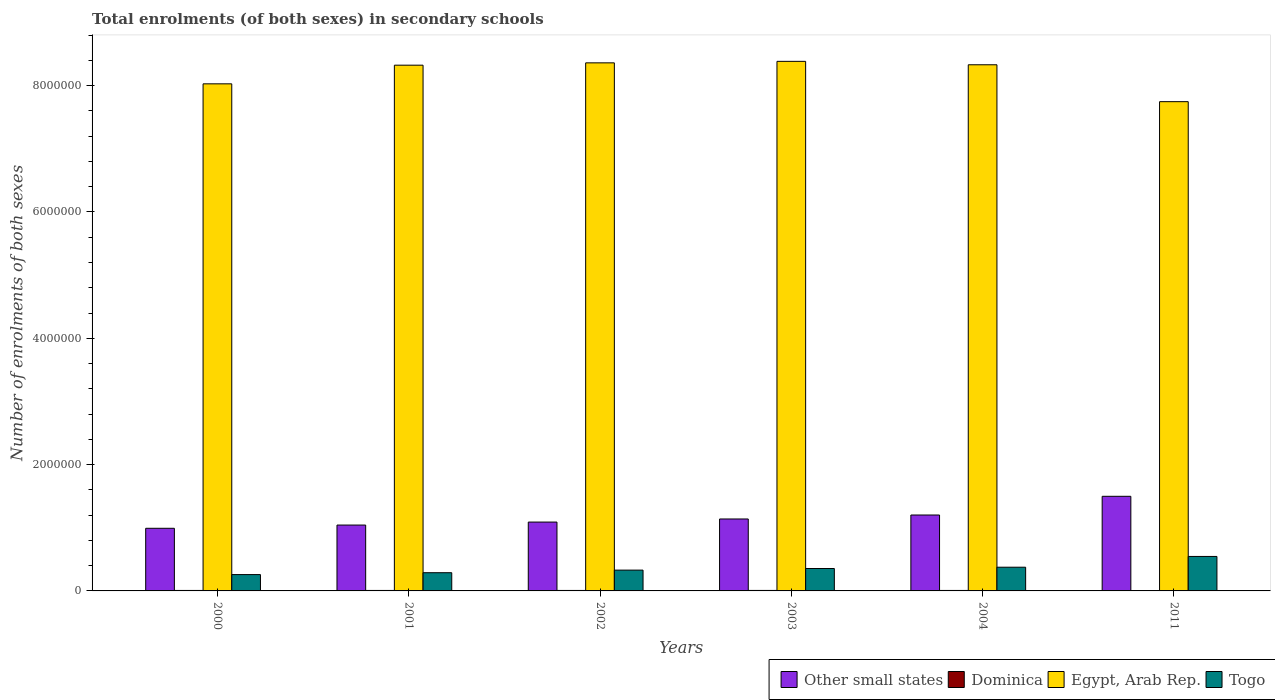How many groups of bars are there?
Provide a succinct answer. 6. Are the number of bars per tick equal to the number of legend labels?
Keep it short and to the point. Yes. How many bars are there on the 2nd tick from the left?
Make the answer very short. 4. In how many cases, is the number of bars for a given year not equal to the number of legend labels?
Provide a short and direct response. 0. What is the number of enrolments in secondary schools in Other small states in 2004?
Give a very brief answer. 1.20e+06. Across all years, what is the maximum number of enrolments in secondary schools in Dominica?
Provide a succinct answer. 7724. Across all years, what is the minimum number of enrolments in secondary schools in Dominica?
Offer a very short reply. 6507. What is the total number of enrolments in secondary schools in Dominica in the graph?
Your response must be concise. 4.41e+04. What is the difference between the number of enrolments in secondary schools in Togo in 2001 and that in 2003?
Keep it short and to the point. -6.66e+04. What is the difference between the number of enrolments in secondary schools in Other small states in 2011 and the number of enrolments in secondary schools in Egypt, Arab Rep. in 2002?
Provide a short and direct response. -6.86e+06. What is the average number of enrolments in secondary schools in Togo per year?
Provide a succinct answer. 3.59e+05. In the year 2004, what is the difference between the number of enrolments in secondary schools in Other small states and number of enrolments in secondary schools in Togo?
Make the answer very short. 8.26e+05. In how many years, is the number of enrolments in secondary schools in Togo greater than 1600000?
Give a very brief answer. 0. What is the ratio of the number of enrolments in secondary schools in Dominica in 2001 to that in 2004?
Offer a terse response. 1. Is the difference between the number of enrolments in secondary schools in Other small states in 2000 and 2004 greater than the difference between the number of enrolments in secondary schools in Togo in 2000 and 2004?
Offer a very short reply. No. What is the difference between the highest and the second highest number of enrolments in secondary schools in Egypt, Arab Rep.?
Offer a very short reply. 2.37e+04. What is the difference between the highest and the lowest number of enrolments in secondary schools in Other small states?
Provide a succinct answer. 5.06e+05. Is it the case that in every year, the sum of the number of enrolments in secondary schools in Egypt, Arab Rep. and number of enrolments in secondary schools in Togo is greater than the sum of number of enrolments in secondary schools in Dominica and number of enrolments in secondary schools in Other small states?
Make the answer very short. Yes. What does the 1st bar from the left in 2002 represents?
Make the answer very short. Other small states. What does the 1st bar from the right in 2000 represents?
Make the answer very short. Togo. How many bars are there?
Keep it short and to the point. 24. What is the difference between two consecutive major ticks on the Y-axis?
Offer a terse response. 2.00e+06. Are the values on the major ticks of Y-axis written in scientific E-notation?
Provide a short and direct response. No. Does the graph contain grids?
Give a very brief answer. No. What is the title of the graph?
Offer a terse response. Total enrolments (of both sexes) in secondary schools. Does "Bangladesh" appear as one of the legend labels in the graph?
Make the answer very short. No. What is the label or title of the X-axis?
Give a very brief answer. Years. What is the label or title of the Y-axis?
Provide a short and direct response. Number of enrolments of both sexes. What is the Number of enrolments of both sexes in Other small states in 2000?
Provide a succinct answer. 9.92e+05. What is the Number of enrolments of both sexes of Dominica in 2000?
Make the answer very short. 7429. What is the Number of enrolments of both sexes of Egypt, Arab Rep. in 2000?
Offer a very short reply. 8.03e+06. What is the Number of enrolments of both sexes in Togo in 2000?
Your answer should be very brief. 2.59e+05. What is the Number of enrolments of both sexes of Other small states in 2001?
Provide a succinct answer. 1.04e+06. What is the Number of enrolments of both sexes in Dominica in 2001?
Your answer should be compact. 7456. What is the Number of enrolments of both sexes of Egypt, Arab Rep. in 2001?
Your answer should be compact. 8.32e+06. What is the Number of enrolments of both sexes of Togo in 2001?
Your answer should be compact. 2.88e+05. What is the Number of enrolments of both sexes in Other small states in 2002?
Your answer should be very brief. 1.09e+06. What is the Number of enrolments of both sexes in Dominica in 2002?
Your answer should be compact. 7500. What is the Number of enrolments of both sexes in Egypt, Arab Rep. in 2002?
Give a very brief answer. 8.36e+06. What is the Number of enrolments of both sexes of Togo in 2002?
Give a very brief answer. 3.29e+05. What is the Number of enrolments of both sexes of Other small states in 2003?
Offer a terse response. 1.14e+06. What is the Number of enrolments of both sexes of Dominica in 2003?
Offer a terse response. 7724. What is the Number of enrolments of both sexes in Egypt, Arab Rep. in 2003?
Provide a succinct answer. 8.38e+06. What is the Number of enrolments of both sexes in Togo in 2003?
Offer a very short reply. 3.55e+05. What is the Number of enrolments of both sexes of Other small states in 2004?
Offer a very short reply. 1.20e+06. What is the Number of enrolments of both sexes in Dominica in 2004?
Your answer should be compact. 7477. What is the Number of enrolments of both sexes in Egypt, Arab Rep. in 2004?
Give a very brief answer. 8.33e+06. What is the Number of enrolments of both sexes in Togo in 2004?
Make the answer very short. 3.75e+05. What is the Number of enrolments of both sexes of Other small states in 2011?
Make the answer very short. 1.50e+06. What is the Number of enrolments of both sexes in Dominica in 2011?
Provide a short and direct response. 6507. What is the Number of enrolments of both sexes in Egypt, Arab Rep. in 2011?
Your response must be concise. 7.75e+06. What is the Number of enrolments of both sexes in Togo in 2011?
Give a very brief answer. 5.46e+05. Across all years, what is the maximum Number of enrolments of both sexes in Other small states?
Offer a very short reply. 1.50e+06. Across all years, what is the maximum Number of enrolments of both sexes in Dominica?
Keep it short and to the point. 7724. Across all years, what is the maximum Number of enrolments of both sexes of Egypt, Arab Rep.?
Provide a short and direct response. 8.38e+06. Across all years, what is the maximum Number of enrolments of both sexes in Togo?
Provide a short and direct response. 5.46e+05. Across all years, what is the minimum Number of enrolments of both sexes of Other small states?
Provide a short and direct response. 9.92e+05. Across all years, what is the minimum Number of enrolments of both sexes in Dominica?
Your answer should be very brief. 6507. Across all years, what is the minimum Number of enrolments of both sexes of Egypt, Arab Rep.?
Offer a terse response. 7.75e+06. Across all years, what is the minimum Number of enrolments of both sexes of Togo?
Your answer should be compact. 2.59e+05. What is the total Number of enrolments of both sexes in Other small states in the graph?
Offer a terse response. 6.96e+06. What is the total Number of enrolments of both sexes of Dominica in the graph?
Offer a terse response. 4.41e+04. What is the total Number of enrolments of both sexes in Egypt, Arab Rep. in the graph?
Offer a very short reply. 4.92e+07. What is the total Number of enrolments of both sexes of Togo in the graph?
Provide a short and direct response. 2.15e+06. What is the difference between the Number of enrolments of both sexes in Other small states in 2000 and that in 2001?
Ensure brevity in your answer.  -5.12e+04. What is the difference between the Number of enrolments of both sexes in Dominica in 2000 and that in 2001?
Offer a very short reply. -27. What is the difference between the Number of enrolments of both sexes of Egypt, Arab Rep. in 2000 and that in 2001?
Provide a succinct answer. -2.95e+05. What is the difference between the Number of enrolments of both sexes of Togo in 2000 and that in 2001?
Make the answer very short. -2.97e+04. What is the difference between the Number of enrolments of both sexes in Other small states in 2000 and that in 2002?
Give a very brief answer. -9.85e+04. What is the difference between the Number of enrolments of both sexes in Dominica in 2000 and that in 2002?
Provide a succinct answer. -71. What is the difference between the Number of enrolments of both sexes of Egypt, Arab Rep. in 2000 and that in 2002?
Your response must be concise. -3.32e+05. What is the difference between the Number of enrolments of both sexes of Togo in 2000 and that in 2002?
Keep it short and to the point. -7.06e+04. What is the difference between the Number of enrolments of both sexes of Other small states in 2000 and that in 2003?
Your answer should be compact. -1.48e+05. What is the difference between the Number of enrolments of both sexes in Dominica in 2000 and that in 2003?
Your answer should be compact. -295. What is the difference between the Number of enrolments of both sexes in Egypt, Arab Rep. in 2000 and that in 2003?
Offer a very short reply. -3.56e+05. What is the difference between the Number of enrolments of both sexes in Togo in 2000 and that in 2003?
Your response must be concise. -9.63e+04. What is the difference between the Number of enrolments of both sexes in Other small states in 2000 and that in 2004?
Provide a succinct answer. -2.10e+05. What is the difference between the Number of enrolments of both sexes of Dominica in 2000 and that in 2004?
Provide a short and direct response. -48. What is the difference between the Number of enrolments of both sexes of Egypt, Arab Rep. in 2000 and that in 2004?
Ensure brevity in your answer.  -3.02e+05. What is the difference between the Number of enrolments of both sexes in Togo in 2000 and that in 2004?
Give a very brief answer. -1.17e+05. What is the difference between the Number of enrolments of both sexes of Other small states in 2000 and that in 2011?
Provide a short and direct response. -5.06e+05. What is the difference between the Number of enrolments of both sexes of Dominica in 2000 and that in 2011?
Make the answer very short. 922. What is the difference between the Number of enrolments of both sexes of Egypt, Arab Rep. in 2000 and that in 2011?
Your answer should be very brief. 2.82e+05. What is the difference between the Number of enrolments of both sexes in Togo in 2000 and that in 2011?
Ensure brevity in your answer.  -2.87e+05. What is the difference between the Number of enrolments of both sexes in Other small states in 2001 and that in 2002?
Keep it short and to the point. -4.73e+04. What is the difference between the Number of enrolments of both sexes of Dominica in 2001 and that in 2002?
Your answer should be compact. -44. What is the difference between the Number of enrolments of both sexes in Egypt, Arab Rep. in 2001 and that in 2002?
Offer a very short reply. -3.67e+04. What is the difference between the Number of enrolments of both sexes of Togo in 2001 and that in 2002?
Provide a succinct answer. -4.10e+04. What is the difference between the Number of enrolments of both sexes of Other small states in 2001 and that in 2003?
Provide a short and direct response. -9.63e+04. What is the difference between the Number of enrolments of both sexes in Dominica in 2001 and that in 2003?
Provide a succinct answer. -268. What is the difference between the Number of enrolments of both sexes of Egypt, Arab Rep. in 2001 and that in 2003?
Make the answer very short. -6.05e+04. What is the difference between the Number of enrolments of both sexes in Togo in 2001 and that in 2003?
Give a very brief answer. -6.66e+04. What is the difference between the Number of enrolments of both sexes of Other small states in 2001 and that in 2004?
Ensure brevity in your answer.  -1.59e+05. What is the difference between the Number of enrolments of both sexes of Egypt, Arab Rep. in 2001 and that in 2004?
Give a very brief answer. -6225. What is the difference between the Number of enrolments of both sexes of Togo in 2001 and that in 2004?
Your answer should be compact. -8.70e+04. What is the difference between the Number of enrolments of both sexes of Other small states in 2001 and that in 2011?
Ensure brevity in your answer.  -4.55e+05. What is the difference between the Number of enrolments of both sexes of Dominica in 2001 and that in 2011?
Your answer should be very brief. 949. What is the difference between the Number of enrolments of both sexes of Egypt, Arab Rep. in 2001 and that in 2011?
Offer a terse response. 5.78e+05. What is the difference between the Number of enrolments of both sexes of Togo in 2001 and that in 2011?
Keep it short and to the point. -2.58e+05. What is the difference between the Number of enrolments of both sexes of Other small states in 2002 and that in 2003?
Keep it short and to the point. -4.90e+04. What is the difference between the Number of enrolments of both sexes in Dominica in 2002 and that in 2003?
Your answer should be very brief. -224. What is the difference between the Number of enrolments of both sexes in Egypt, Arab Rep. in 2002 and that in 2003?
Your answer should be very brief. -2.37e+04. What is the difference between the Number of enrolments of both sexes in Togo in 2002 and that in 2003?
Your answer should be very brief. -2.57e+04. What is the difference between the Number of enrolments of both sexes in Other small states in 2002 and that in 2004?
Offer a very short reply. -1.12e+05. What is the difference between the Number of enrolments of both sexes in Dominica in 2002 and that in 2004?
Keep it short and to the point. 23. What is the difference between the Number of enrolments of both sexes in Egypt, Arab Rep. in 2002 and that in 2004?
Give a very brief answer. 3.05e+04. What is the difference between the Number of enrolments of both sexes of Togo in 2002 and that in 2004?
Your answer should be compact. -4.61e+04. What is the difference between the Number of enrolments of both sexes of Other small states in 2002 and that in 2011?
Provide a short and direct response. -4.08e+05. What is the difference between the Number of enrolments of both sexes of Dominica in 2002 and that in 2011?
Your response must be concise. 993. What is the difference between the Number of enrolments of both sexes of Egypt, Arab Rep. in 2002 and that in 2011?
Provide a succinct answer. 6.14e+05. What is the difference between the Number of enrolments of both sexes of Togo in 2002 and that in 2011?
Make the answer very short. -2.17e+05. What is the difference between the Number of enrolments of both sexes of Other small states in 2003 and that in 2004?
Provide a succinct answer. -6.28e+04. What is the difference between the Number of enrolments of both sexes in Dominica in 2003 and that in 2004?
Your response must be concise. 247. What is the difference between the Number of enrolments of both sexes in Egypt, Arab Rep. in 2003 and that in 2004?
Provide a succinct answer. 5.42e+04. What is the difference between the Number of enrolments of both sexes in Togo in 2003 and that in 2004?
Offer a very short reply. -2.04e+04. What is the difference between the Number of enrolments of both sexes in Other small states in 2003 and that in 2011?
Your answer should be very brief. -3.59e+05. What is the difference between the Number of enrolments of both sexes of Dominica in 2003 and that in 2011?
Provide a short and direct response. 1217. What is the difference between the Number of enrolments of both sexes of Egypt, Arab Rep. in 2003 and that in 2011?
Keep it short and to the point. 6.38e+05. What is the difference between the Number of enrolments of both sexes of Togo in 2003 and that in 2011?
Your answer should be compact. -1.91e+05. What is the difference between the Number of enrolments of both sexes of Other small states in 2004 and that in 2011?
Your response must be concise. -2.96e+05. What is the difference between the Number of enrolments of both sexes in Dominica in 2004 and that in 2011?
Provide a succinct answer. 970. What is the difference between the Number of enrolments of both sexes in Egypt, Arab Rep. in 2004 and that in 2011?
Your response must be concise. 5.84e+05. What is the difference between the Number of enrolments of both sexes in Togo in 2004 and that in 2011?
Provide a short and direct response. -1.70e+05. What is the difference between the Number of enrolments of both sexes in Other small states in 2000 and the Number of enrolments of both sexes in Dominica in 2001?
Provide a short and direct response. 9.84e+05. What is the difference between the Number of enrolments of both sexes of Other small states in 2000 and the Number of enrolments of both sexes of Egypt, Arab Rep. in 2001?
Give a very brief answer. -7.33e+06. What is the difference between the Number of enrolments of both sexes of Other small states in 2000 and the Number of enrolments of both sexes of Togo in 2001?
Offer a terse response. 7.03e+05. What is the difference between the Number of enrolments of both sexes in Dominica in 2000 and the Number of enrolments of both sexes in Egypt, Arab Rep. in 2001?
Your answer should be very brief. -8.32e+06. What is the difference between the Number of enrolments of both sexes of Dominica in 2000 and the Number of enrolments of both sexes of Togo in 2001?
Your answer should be very brief. -2.81e+05. What is the difference between the Number of enrolments of both sexes in Egypt, Arab Rep. in 2000 and the Number of enrolments of both sexes in Togo in 2001?
Offer a terse response. 7.74e+06. What is the difference between the Number of enrolments of both sexes of Other small states in 2000 and the Number of enrolments of both sexes of Dominica in 2002?
Your answer should be compact. 9.84e+05. What is the difference between the Number of enrolments of both sexes of Other small states in 2000 and the Number of enrolments of both sexes of Egypt, Arab Rep. in 2002?
Your response must be concise. -7.37e+06. What is the difference between the Number of enrolments of both sexes in Other small states in 2000 and the Number of enrolments of both sexes in Togo in 2002?
Your answer should be very brief. 6.62e+05. What is the difference between the Number of enrolments of both sexes in Dominica in 2000 and the Number of enrolments of both sexes in Egypt, Arab Rep. in 2002?
Your answer should be very brief. -8.35e+06. What is the difference between the Number of enrolments of both sexes in Dominica in 2000 and the Number of enrolments of both sexes in Togo in 2002?
Keep it short and to the point. -3.22e+05. What is the difference between the Number of enrolments of both sexes in Egypt, Arab Rep. in 2000 and the Number of enrolments of both sexes in Togo in 2002?
Offer a terse response. 7.70e+06. What is the difference between the Number of enrolments of both sexes of Other small states in 2000 and the Number of enrolments of both sexes of Dominica in 2003?
Provide a succinct answer. 9.84e+05. What is the difference between the Number of enrolments of both sexes in Other small states in 2000 and the Number of enrolments of both sexes in Egypt, Arab Rep. in 2003?
Your response must be concise. -7.39e+06. What is the difference between the Number of enrolments of both sexes in Other small states in 2000 and the Number of enrolments of both sexes in Togo in 2003?
Make the answer very short. 6.37e+05. What is the difference between the Number of enrolments of both sexes in Dominica in 2000 and the Number of enrolments of both sexes in Egypt, Arab Rep. in 2003?
Offer a terse response. -8.38e+06. What is the difference between the Number of enrolments of both sexes in Dominica in 2000 and the Number of enrolments of both sexes in Togo in 2003?
Provide a short and direct response. -3.48e+05. What is the difference between the Number of enrolments of both sexes in Egypt, Arab Rep. in 2000 and the Number of enrolments of both sexes in Togo in 2003?
Make the answer very short. 7.67e+06. What is the difference between the Number of enrolments of both sexes in Other small states in 2000 and the Number of enrolments of both sexes in Dominica in 2004?
Your answer should be compact. 9.84e+05. What is the difference between the Number of enrolments of both sexes of Other small states in 2000 and the Number of enrolments of both sexes of Egypt, Arab Rep. in 2004?
Your answer should be very brief. -7.34e+06. What is the difference between the Number of enrolments of both sexes of Other small states in 2000 and the Number of enrolments of both sexes of Togo in 2004?
Provide a succinct answer. 6.16e+05. What is the difference between the Number of enrolments of both sexes of Dominica in 2000 and the Number of enrolments of both sexes of Egypt, Arab Rep. in 2004?
Ensure brevity in your answer.  -8.32e+06. What is the difference between the Number of enrolments of both sexes in Dominica in 2000 and the Number of enrolments of both sexes in Togo in 2004?
Offer a terse response. -3.68e+05. What is the difference between the Number of enrolments of both sexes in Egypt, Arab Rep. in 2000 and the Number of enrolments of both sexes in Togo in 2004?
Provide a succinct answer. 7.65e+06. What is the difference between the Number of enrolments of both sexes of Other small states in 2000 and the Number of enrolments of both sexes of Dominica in 2011?
Provide a short and direct response. 9.85e+05. What is the difference between the Number of enrolments of both sexes in Other small states in 2000 and the Number of enrolments of both sexes in Egypt, Arab Rep. in 2011?
Your answer should be very brief. -6.75e+06. What is the difference between the Number of enrolments of both sexes in Other small states in 2000 and the Number of enrolments of both sexes in Togo in 2011?
Your response must be concise. 4.46e+05. What is the difference between the Number of enrolments of both sexes in Dominica in 2000 and the Number of enrolments of both sexes in Egypt, Arab Rep. in 2011?
Ensure brevity in your answer.  -7.74e+06. What is the difference between the Number of enrolments of both sexes in Dominica in 2000 and the Number of enrolments of both sexes in Togo in 2011?
Keep it short and to the point. -5.38e+05. What is the difference between the Number of enrolments of both sexes of Egypt, Arab Rep. in 2000 and the Number of enrolments of both sexes of Togo in 2011?
Your answer should be compact. 7.48e+06. What is the difference between the Number of enrolments of both sexes in Other small states in 2001 and the Number of enrolments of both sexes in Dominica in 2002?
Your response must be concise. 1.04e+06. What is the difference between the Number of enrolments of both sexes of Other small states in 2001 and the Number of enrolments of both sexes of Egypt, Arab Rep. in 2002?
Make the answer very short. -7.32e+06. What is the difference between the Number of enrolments of both sexes in Other small states in 2001 and the Number of enrolments of both sexes in Togo in 2002?
Your answer should be compact. 7.13e+05. What is the difference between the Number of enrolments of both sexes of Dominica in 2001 and the Number of enrolments of both sexes of Egypt, Arab Rep. in 2002?
Provide a succinct answer. -8.35e+06. What is the difference between the Number of enrolments of both sexes in Dominica in 2001 and the Number of enrolments of both sexes in Togo in 2002?
Make the answer very short. -3.22e+05. What is the difference between the Number of enrolments of both sexes of Egypt, Arab Rep. in 2001 and the Number of enrolments of both sexes of Togo in 2002?
Keep it short and to the point. 7.99e+06. What is the difference between the Number of enrolments of both sexes in Other small states in 2001 and the Number of enrolments of both sexes in Dominica in 2003?
Your answer should be compact. 1.04e+06. What is the difference between the Number of enrolments of both sexes in Other small states in 2001 and the Number of enrolments of both sexes in Egypt, Arab Rep. in 2003?
Offer a very short reply. -7.34e+06. What is the difference between the Number of enrolments of both sexes of Other small states in 2001 and the Number of enrolments of both sexes of Togo in 2003?
Keep it short and to the point. 6.88e+05. What is the difference between the Number of enrolments of both sexes in Dominica in 2001 and the Number of enrolments of both sexes in Egypt, Arab Rep. in 2003?
Make the answer very short. -8.38e+06. What is the difference between the Number of enrolments of both sexes in Dominica in 2001 and the Number of enrolments of both sexes in Togo in 2003?
Give a very brief answer. -3.48e+05. What is the difference between the Number of enrolments of both sexes in Egypt, Arab Rep. in 2001 and the Number of enrolments of both sexes in Togo in 2003?
Make the answer very short. 7.97e+06. What is the difference between the Number of enrolments of both sexes of Other small states in 2001 and the Number of enrolments of both sexes of Dominica in 2004?
Your response must be concise. 1.04e+06. What is the difference between the Number of enrolments of both sexes in Other small states in 2001 and the Number of enrolments of both sexes in Egypt, Arab Rep. in 2004?
Your response must be concise. -7.29e+06. What is the difference between the Number of enrolments of both sexes of Other small states in 2001 and the Number of enrolments of both sexes of Togo in 2004?
Provide a succinct answer. 6.67e+05. What is the difference between the Number of enrolments of both sexes in Dominica in 2001 and the Number of enrolments of both sexes in Egypt, Arab Rep. in 2004?
Your response must be concise. -8.32e+06. What is the difference between the Number of enrolments of both sexes in Dominica in 2001 and the Number of enrolments of both sexes in Togo in 2004?
Give a very brief answer. -3.68e+05. What is the difference between the Number of enrolments of both sexes in Egypt, Arab Rep. in 2001 and the Number of enrolments of both sexes in Togo in 2004?
Ensure brevity in your answer.  7.95e+06. What is the difference between the Number of enrolments of both sexes in Other small states in 2001 and the Number of enrolments of both sexes in Dominica in 2011?
Ensure brevity in your answer.  1.04e+06. What is the difference between the Number of enrolments of both sexes in Other small states in 2001 and the Number of enrolments of both sexes in Egypt, Arab Rep. in 2011?
Your answer should be very brief. -6.70e+06. What is the difference between the Number of enrolments of both sexes of Other small states in 2001 and the Number of enrolments of both sexes of Togo in 2011?
Offer a terse response. 4.97e+05. What is the difference between the Number of enrolments of both sexes of Dominica in 2001 and the Number of enrolments of both sexes of Egypt, Arab Rep. in 2011?
Give a very brief answer. -7.74e+06. What is the difference between the Number of enrolments of both sexes in Dominica in 2001 and the Number of enrolments of both sexes in Togo in 2011?
Offer a terse response. -5.38e+05. What is the difference between the Number of enrolments of both sexes of Egypt, Arab Rep. in 2001 and the Number of enrolments of both sexes of Togo in 2011?
Your response must be concise. 7.78e+06. What is the difference between the Number of enrolments of both sexes of Other small states in 2002 and the Number of enrolments of both sexes of Dominica in 2003?
Your response must be concise. 1.08e+06. What is the difference between the Number of enrolments of both sexes in Other small states in 2002 and the Number of enrolments of both sexes in Egypt, Arab Rep. in 2003?
Your answer should be very brief. -7.29e+06. What is the difference between the Number of enrolments of both sexes in Other small states in 2002 and the Number of enrolments of both sexes in Togo in 2003?
Offer a terse response. 7.35e+05. What is the difference between the Number of enrolments of both sexes of Dominica in 2002 and the Number of enrolments of both sexes of Egypt, Arab Rep. in 2003?
Give a very brief answer. -8.38e+06. What is the difference between the Number of enrolments of both sexes in Dominica in 2002 and the Number of enrolments of both sexes in Togo in 2003?
Provide a short and direct response. -3.47e+05. What is the difference between the Number of enrolments of both sexes in Egypt, Arab Rep. in 2002 and the Number of enrolments of both sexes in Togo in 2003?
Your answer should be compact. 8.01e+06. What is the difference between the Number of enrolments of both sexes of Other small states in 2002 and the Number of enrolments of both sexes of Dominica in 2004?
Your response must be concise. 1.08e+06. What is the difference between the Number of enrolments of both sexes in Other small states in 2002 and the Number of enrolments of both sexes in Egypt, Arab Rep. in 2004?
Ensure brevity in your answer.  -7.24e+06. What is the difference between the Number of enrolments of both sexes of Other small states in 2002 and the Number of enrolments of both sexes of Togo in 2004?
Your answer should be compact. 7.15e+05. What is the difference between the Number of enrolments of both sexes of Dominica in 2002 and the Number of enrolments of both sexes of Egypt, Arab Rep. in 2004?
Keep it short and to the point. -8.32e+06. What is the difference between the Number of enrolments of both sexes of Dominica in 2002 and the Number of enrolments of both sexes of Togo in 2004?
Offer a very short reply. -3.68e+05. What is the difference between the Number of enrolments of both sexes of Egypt, Arab Rep. in 2002 and the Number of enrolments of both sexes of Togo in 2004?
Provide a short and direct response. 7.98e+06. What is the difference between the Number of enrolments of both sexes of Other small states in 2002 and the Number of enrolments of both sexes of Dominica in 2011?
Offer a terse response. 1.08e+06. What is the difference between the Number of enrolments of both sexes of Other small states in 2002 and the Number of enrolments of both sexes of Egypt, Arab Rep. in 2011?
Your response must be concise. -6.66e+06. What is the difference between the Number of enrolments of both sexes of Other small states in 2002 and the Number of enrolments of both sexes of Togo in 2011?
Give a very brief answer. 5.44e+05. What is the difference between the Number of enrolments of both sexes of Dominica in 2002 and the Number of enrolments of both sexes of Egypt, Arab Rep. in 2011?
Make the answer very short. -7.74e+06. What is the difference between the Number of enrolments of both sexes in Dominica in 2002 and the Number of enrolments of both sexes in Togo in 2011?
Your response must be concise. -5.38e+05. What is the difference between the Number of enrolments of both sexes of Egypt, Arab Rep. in 2002 and the Number of enrolments of both sexes of Togo in 2011?
Keep it short and to the point. 7.81e+06. What is the difference between the Number of enrolments of both sexes of Other small states in 2003 and the Number of enrolments of both sexes of Dominica in 2004?
Give a very brief answer. 1.13e+06. What is the difference between the Number of enrolments of both sexes in Other small states in 2003 and the Number of enrolments of both sexes in Egypt, Arab Rep. in 2004?
Offer a very short reply. -7.19e+06. What is the difference between the Number of enrolments of both sexes of Other small states in 2003 and the Number of enrolments of both sexes of Togo in 2004?
Offer a terse response. 7.64e+05. What is the difference between the Number of enrolments of both sexes of Dominica in 2003 and the Number of enrolments of both sexes of Egypt, Arab Rep. in 2004?
Your answer should be compact. -8.32e+06. What is the difference between the Number of enrolments of both sexes of Dominica in 2003 and the Number of enrolments of both sexes of Togo in 2004?
Ensure brevity in your answer.  -3.68e+05. What is the difference between the Number of enrolments of both sexes of Egypt, Arab Rep. in 2003 and the Number of enrolments of both sexes of Togo in 2004?
Ensure brevity in your answer.  8.01e+06. What is the difference between the Number of enrolments of both sexes in Other small states in 2003 and the Number of enrolments of both sexes in Dominica in 2011?
Offer a terse response. 1.13e+06. What is the difference between the Number of enrolments of both sexes in Other small states in 2003 and the Number of enrolments of both sexes in Egypt, Arab Rep. in 2011?
Offer a terse response. -6.61e+06. What is the difference between the Number of enrolments of both sexes of Other small states in 2003 and the Number of enrolments of both sexes of Togo in 2011?
Ensure brevity in your answer.  5.93e+05. What is the difference between the Number of enrolments of both sexes in Dominica in 2003 and the Number of enrolments of both sexes in Egypt, Arab Rep. in 2011?
Your answer should be compact. -7.74e+06. What is the difference between the Number of enrolments of both sexes of Dominica in 2003 and the Number of enrolments of both sexes of Togo in 2011?
Provide a short and direct response. -5.38e+05. What is the difference between the Number of enrolments of both sexes of Egypt, Arab Rep. in 2003 and the Number of enrolments of both sexes of Togo in 2011?
Provide a short and direct response. 7.84e+06. What is the difference between the Number of enrolments of both sexes of Other small states in 2004 and the Number of enrolments of both sexes of Dominica in 2011?
Provide a succinct answer. 1.20e+06. What is the difference between the Number of enrolments of both sexes of Other small states in 2004 and the Number of enrolments of both sexes of Egypt, Arab Rep. in 2011?
Give a very brief answer. -6.54e+06. What is the difference between the Number of enrolments of both sexes of Other small states in 2004 and the Number of enrolments of both sexes of Togo in 2011?
Provide a short and direct response. 6.56e+05. What is the difference between the Number of enrolments of both sexes in Dominica in 2004 and the Number of enrolments of both sexes in Egypt, Arab Rep. in 2011?
Keep it short and to the point. -7.74e+06. What is the difference between the Number of enrolments of both sexes of Dominica in 2004 and the Number of enrolments of both sexes of Togo in 2011?
Your answer should be very brief. -5.38e+05. What is the difference between the Number of enrolments of both sexes in Egypt, Arab Rep. in 2004 and the Number of enrolments of both sexes in Togo in 2011?
Ensure brevity in your answer.  7.78e+06. What is the average Number of enrolments of both sexes in Other small states per year?
Provide a short and direct response. 1.16e+06. What is the average Number of enrolments of both sexes of Dominica per year?
Ensure brevity in your answer.  7348.83. What is the average Number of enrolments of both sexes in Egypt, Arab Rep. per year?
Provide a short and direct response. 8.20e+06. What is the average Number of enrolments of both sexes of Togo per year?
Provide a succinct answer. 3.59e+05. In the year 2000, what is the difference between the Number of enrolments of both sexes of Other small states and Number of enrolments of both sexes of Dominica?
Provide a succinct answer. 9.84e+05. In the year 2000, what is the difference between the Number of enrolments of both sexes in Other small states and Number of enrolments of both sexes in Egypt, Arab Rep.?
Give a very brief answer. -7.04e+06. In the year 2000, what is the difference between the Number of enrolments of both sexes in Other small states and Number of enrolments of both sexes in Togo?
Offer a terse response. 7.33e+05. In the year 2000, what is the difference between the Number of enrolments of both sexes of Dominica and Number of enrolments of both sexes of Egypt, Arab Rep.?
Provide a succinct answer. -8.02e+06. In the year 2000, what is the difference between the Number of enrolments of both sexes in Dominica and Number of enrolments of both sexes in Togo?
Provide a short and direct response. -2.51e+05. In the year 2000, what is the difference between the Number of enrolments of both sexes of Egypt, Arab Rep. and Number of enrolments of both sexes of Togo?
Ensure brevity in your answer.  7.77e+06. In the year 2001, what is the difference between the Number of enrolments of both sexes of Other small states and Number of enrolments of both sexes of Dominica?
Your answer should be very brief. 1.04e+06. In the year 2001, what is the difference between the Number of enrolments of both sexes in Other small states and Number of enrolments of both sexes in Egypt, Arab Rep.?
Offer a very short reply. -7.28e+06. In the year 2001, what is the difference between the Number of enrolments of both sexes of Other small states and Number of enrolments of both sexes of Togo?
Your answer should be very brief. 7.54e+05. In the year 2001, what is the difference between the Number of enrolments of both sexes of Dominica and Number of enrolments of both sexes of Egypt, Arab Rep.?
Provide a short and direct response. -8.32e+06. In the year 2001, what is the difference between the Number of enrolments of both sexes of Dominica and Number of enrolments of both sexes of Togo?
Ensure brevity in your answer.  -2.81e+05. In the year 2001, what is the difference between the Number of enrolments of both sexes of Egypt, Arab Rep. and Number of enrolments of both sexes of Togo?
Your answer should be very brief. 8.04e+06. In the year 2002, what is the difference between the Number of enrolments of both sexes of Other small states and Number of enrolments of both sexes of Dominica?
Offer a very short reply. 1.08e+06. In the year 2002, what is the difference between the Number of enrolments of both sexes in Other small states and Number of enrolments of both sexes in Egypt, Arab Rep.?
Provide a short and direct response. -7.27e+06. In the year 2002, what is the difference between the Number of enrolments of both sexes of Other small states and Number of enrolments of both sexes of Togo?
Offer a very short reply. 7.61e+05. In the year 2002, what is the difference between the Number of enrolments of both sexes of Dominica and Number of enrolments of both sexes of Egypt, Arab Rep.?
Your answer should be compact. -8.35e+06. In the year 2002, what is the difference between the Number of enrolments of both sexes in Dominica and Number of enrolments of both sexes in Togo?
Ensure brevity in your answer.  -3.22e+05. In the year 2002, what is the difference between the Number of enrolments of both sexes in Egypt, Arab Rep. and Number of enrolments of both sexes in Togo?
Ensure brevity in your answer.  8.03e+06. In the year 2003, what is the difference between the Number of enrolments of both sexes of Other small states and Number of enrolments of both sexes of Dominica?
Ensure brevity in your answer.  1.13e+06. In the year 2003, what is the difference between the Number of enrolments of both sexes of Other small states and Number of enrolments of both sexes of Egypt, Arab Rep.?
Keep it short and to the point. -7.24e+06. In the year 2003, what is the difference between the Number of enrolments of both sexes of Other small states and Number of enrolments of both sexes of Togo?
Provide a short and direct response. 7.84e+05. In the year 2003, what is the difference between the Number of enrolments of both sexes of Dominica and Number of enrolments of both sexes of Egypt, Arab Rep.?
Ensure brevity in your answer.  -8.38e+06. In the year 2003, what is the difference between the Number of enrolments of both sexes in Dominica and Number of enrolments of both sexes in Togo?
Offer a very short reply. -3.47e+05. In the year 2003, what is the difference between the Number of enrolments of both sexes in Egypt, Arab Rep. and Number of enrolments of both sexes in Togo?
Offer a terse response. 8.03e+06. In the year 2004, what is the difference between the Number of enrolments of both sexes in Other small states and Number of enrolments of both sexes in Dominica?
Offer a terse response. 1.19e+06. In the year 2004, what is the difference between the Number of enrolments of both sexes of Other small states and Number of enrolments of both sexes of Egypt, Arab Rep.?
Provide a succinct answer. -7.13e+06. In the year 2004, what is the difference between the Number of enrolments of both sexes of Other small states and Number of enrolments of both sexes of Togo?
Keep it short and to the point. 8.26e+05. In the year 2004, what is the difference between the Number of enrolments of both sexes of Dominica and Number of enrolments of both sexes of Egypt, Arab Rep.?
Provide a succinct answer. -8.32e+06. In the year 2004, what is the difference between the Number of enrolments of both sexes of Dominica and Number of enrolments of both sexes of Togo?
Your answer should be very brief. -3.68e+05. In the year 2004, what is the difference between the Number of enrolments of both sexes of Egypt, Arab Rep. and Number of enrolments of both sexes of Togo?
Offer a terse response. 7.95e+06. In the year 2011, what is the difference between the Number of enrolments of both sexes of Other small states and Number of enrolments of both sexes of Dominica?
Give a very brief answer. 1.49e+06. In the year 2011, what is the difference between the Number of enrolments of both sexes in Other small states and Number of enrolments of both sexes in Egypt, Arab Rep.?
Make the answer very short. -6.25e+06. In the year 2011, what is the difference between the Number of enrolments of both sexes of Other small states and Number of enrolments of both sexes of Togo?
Give a very brief answer. 9.52e+05. In the year 2011, what is the difference between the Number of enrolments of both sexes in Dominica and Number of enrolments of both sexes in Egypt, Arab Rep.?
Your answer should be very brief. -7.74e+06. In the year 2011, what is the difference between the Number of enrolments of both sexes of Dominica and Number of enrolments of both sexes of Togo?
Give a very brief answer. -5.39e+05. In the year 2011, what is the difference between the Number of enrolments of both sexes in Egypt, Arab Rep. and Number of enrolments of both sexes in Togo?
Your answer should be very brief. 7.20e+06. What is the ratio of the Number of enrolments of both sexes in Other small states in 2000 to that in 2001?
Offer a terse response. 0.95. What is the ratio of the Number of enrolments of both sexes in Dominica in 2000 to that in 2001?
Your answer should be very brief. 1. What is the ratio of the Number of enrolments of both sexes in Egypt, Arab Rep. in 2000 to that in 2001?
Provide a succinct answer. 0.96. What is the ratio of the Number of enrolments of both sexes in Togo in 2000 to that in 2001?
Offer a terse response. 0.9. What is the ratio of the Number of enrolments of both sexes in Other small states in 2000 to that in 2002?
Make the answer very short. 0.91. What is the ratio of the Number of enrolments of both sexes of Egypt, Arab Rep. in 2000 to that in 2002?
Give a very brief answer. 0.96. What is the ratio of the Number of enrolments of both sexes in Togo in 2000 to that in 2002?
Give a very brief answer. 0.79. What is the ratio of the Number of enrolments of both sexes in Other small states in 2000 to that in 2003?
Give a very brief answer. 0.87. What is the ratio of the Number of enrolments of both sexes of Dominica in 2000 to that in 2003?
Offer a very short reply. 0.96. What is the ratio of the Number of enrolments of both sexes in Egypt, Arab Rep. in 2000 to that in 2003?
Your answer should be very brief. 0.96. What is the ratio of the Number of enrolments of both sexes of Togo in 2000 to that in 2003?
Provide a succinct answer. 0.73. What is the ratio of the Number of enrolments of both sexes of Other small states in 2000 to that in 2004?
Offer a very short reply. 0.82. What is the ratio of the Number of enrolments of both sexes in Egypt, Arab Rep. in 2000 to that in 2004?
Give a very brief answer. 0.96. What is the ratio of the Number of enrolments of both sexes in Togo in 2000 to that in 2004?
Provide a succinct answer. 0.69. What is the ratio of the Number of enrolments of both sexes in Other small states in 2000 to that in 2011?
Provide a short and direct response. 0.66. What is the ratio of the Number of enrolments of both sexes in Dominica in 2000 to that in 2011?
Make the answer very short. 1.14. What is the ratio of the Number of enrolments of both sexes in Egypt, Arab Rep. in 2000 to that in 2011?
Give a very brief answer. 1.04. What is the ratio of the Number of enrolments of both sexes in Togo in 2000 to that in 2011?
Offer a very short reply. 0.47. What is the ratio of the Number of enrolments of both sexes of Other small states in 2001 to that in 2002?
Provide a short and direct response. 0.96. What is the ratio of the Number of enrolments of both sexes in Egypt, Arab Rep. in 2001 to that in 2002?
Offer a very short reply. 1. What is the ratio of the Number of enrolments of both sexes in Togo in 2001 to that in 2002?
Offer a very short reply. 0.88. What is the ratio of the Number of enrolments of both sexes in Other small states in 2001 to that in 2003?
Provide a succinct answer. 0.92. What is the ratio of the Number of enrolments of both sexes of Dominica in 2001 to that in 2003?
Give a very brief answer. 0.97. What is the ratio of the Number of enrolments of both sexes in Egypt, Arab Rep. in 2001 to that in 2003?
Give a very brief answer. 0.99. What is the ratio of the Number of enrolments of both sexes of Togo in 2001 to that in 2003?
Provide a succinct answer. 0.81. What is the ratio of the Number of enrolments of both sexes in Other small states in 2001 to that in 2004?
Your answer should be very brief. 0.87. What is the ratio of the Number of enrolments of both sexes of Togo in 2001 to that in 2004?
Keep it short and to the point. 0.77. What is the ratio of the Number of enrolments of both sexes of Other small states in 2001 to that in 2011?
Your answer should be compact. 0.7. What is the ratio of the Number of enrolments of both sexes in Dominica in 2001 to that in 2011?
Give a very brief answer. 1.15. What is the ratio of the Number of enrolments of both sexes in Egypt, Arab Rep. in 2001 to that in 2011?
Make the answer very short. 1.07. What is the ratio of the Number of enrolments of both sexes in Togo in 2001 to that in 2011?
Your answer should be compact. 0.53. What is the ratio of the Number of enrolments of both sexes of Other small states in 2002 to that in 2003?
Keep it short and to the point. 0.96. What is the ratio of the Number of enrolments of both sexes of Dominica in 2002 to that in 2003?
Offer a terse response. 0.97. What is the ratio of the Number of enrolments of both sexes of Egypt, Arab Rep. in 2002 to that in 2003?
Ensure brevity in your answer.  1. What is the ratio of the Number of enrolments of both sexes of Togo in 2002 to that in 2003?
Your answer should be very brief. 0.93. What is the ratio of the Number of enrolments of both sexes of Other small states in 2002 to that in 2004?
Keep it short and to the point. 0.91. What is the ratio of the Number of enrolments of both sexes in Egypt, Arab Rep. in 2002 to that in 2004?
Make the answer very short. 1. What is the ratio of the Number of enrolments of both sexes in Togo in 2002 to that in 2004?
Your answer should be very brief. 0.88. What is the ratio of the Number of enrolments of both sexes of Other small states in 2002 to that in 2011?
Your answer should be compact. 0.73. What is the ratio of the Number of enrolments of both sexes in Dominica in 2002 to that in 2011?
Offer a terse response. 1.15. What is the ratio of the Number of enrolments of both sexes of Egypt, Arab Rep. in 2002 to that in 2011?
Your answer should be very brief. 1.08. What is the ratio of the Number of enrolments of both sexes of Togo in 2002 to that in 2011?
Keep it short and to the point. 0.6. What is the ratio of the Number of enrolments of both sexes in Other small states in 2003 to that in 2004?
Keep it short and to the point. 0.95. What is the ratio of the Number of enrolments of both sexes in Dominica in 2003 to that in 2004?
Provide a succinct answer. 1.03. What is the ratio of the Number of enrolments of both sexes of Egypt, Arab Rep. in 2003 to that in 2004?
Offer a very short reply. 1.01. What is the ratio of the Number of enrolments of both sexes of Togo in 2003 to that in 2004?
Provide a short and direct response. 0.95. What is the ratio of the Number of enrolments of both sexes of Other small states in 2003 to that in 2011?
Provide a short and direct response. 0.76. What is the ratio of the Number of enrolments of both sexes in Dominica in 2003 to that in 2011?
Your answer should be very brief. 1.19. What is the ratio of the Number of enrolments of both sexes of Egypt, Arab Rep. in 2003 to that in 2011?
Give a very brief answer. 1.08. What is the ratio of the Number of enrolments of both sexes of Togo in 2003 to that in 2011?
Provide a short and direct response. 0.65. What is the ratio of the Number of enrolments of both sexes of Other small states in 2004 to that in 2011?
Your response must be concise. 0.8. What is the ratio of the Number of enrolments of both sexes in Dominica in 2004 to that in 2011?
Give a very brief answer. 1.15. What is the ratio of the Number of enrolments of both sexes of Egypt, Arab Rep. in 2004 to that in 2011?
Your answer should be very brief. 1.08. What is the ratio of the Number of enrolments of both sexes of Togo in 2004 to that in 2011?
Ensure brevity in your answer.  0.69. What is the difference between the highest and the second highest Number of enrolments of both sexes of Other small states?
Offer a terse response. 2.96e+05. What is the difference between the highest and the second highest Number of enrolments of both sexes of Dominica?
Provide a short and direct response. 224. What is the difference between the highest and the second highest Number of enrolments of both sexes in Egypt, Arab Rep.?
Offer a terse response. 2.37e+04. What is the difference between the highest and the second highest Number of enrolments of both sexes of Togo?
Provide a succinct answer. 1.70e+05. What is the difference between the highest and the lowest Number of enrolments of both sexes in Other small states?
Make the answer very short. 5.06e+05. What is the difference between the highest and the lowest Number of enrolments of both sexes of Dominica?
Your answer should be very brief. 1217. What is the difference between the highest and the lowest Number of enrolments of both sexes in Egypt, Arab Rep.?
Give a very brief answer. 6.38e+05. What is the difference between the highest and the lowest Number of enrolments of both sexes of Togo?
Provide a succinct answer. 2.87e+05. 